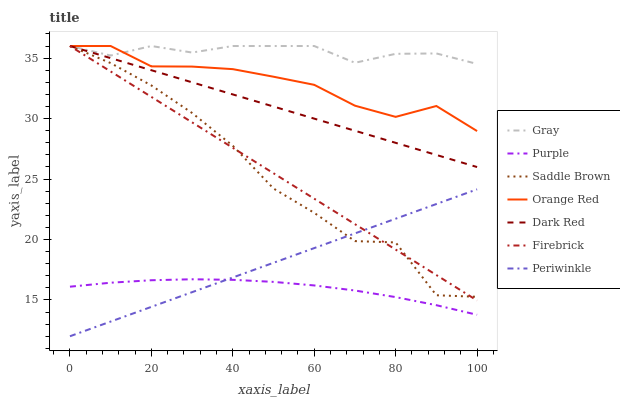Does Purple have the minimum area under the curve?
Answer yes or no. Yes. Does Gray have the maximum area under the curve?
Answer yes or no. Yes. Does Dark Red have the minimum area under the curve?
Answer yes or no. No. Does Dark Red have the maximum area under the curve?
Answer yes or no. No. Is Periwinkle the smoothest?
Answer yes or no. Yes. Is Saddle Brown the roughest?
Answer yes or no. Yes. Is Purple the smoothest?
Answer yes or no. No. Is Purple the roughest?
Answer yes or no. No. Does Periwinkle have the lowest value?
Answer yes or no. Yes. Does Purple have the lowest value?
Answer yes or no. No. Does Saddle Brown have the highest value?
Answer yes or no. Yes. Does Purple have the highest value?
Answer yes or no. No. Is Purple less than Gray?
Answer yes or no. Yes. Is Orange Red greater than Periwinkle?
Answer yes or no. Yes. Does Firebrick intersect Orange Red?
Answer yes or no. Yes. Is Firebrick less than Orange Red?
Answer yes or no. No. Is Firebrick greater than Orange Red?
Answer yes or no. No. Does Purple intersect Gray?
Answer yes or no. No. 